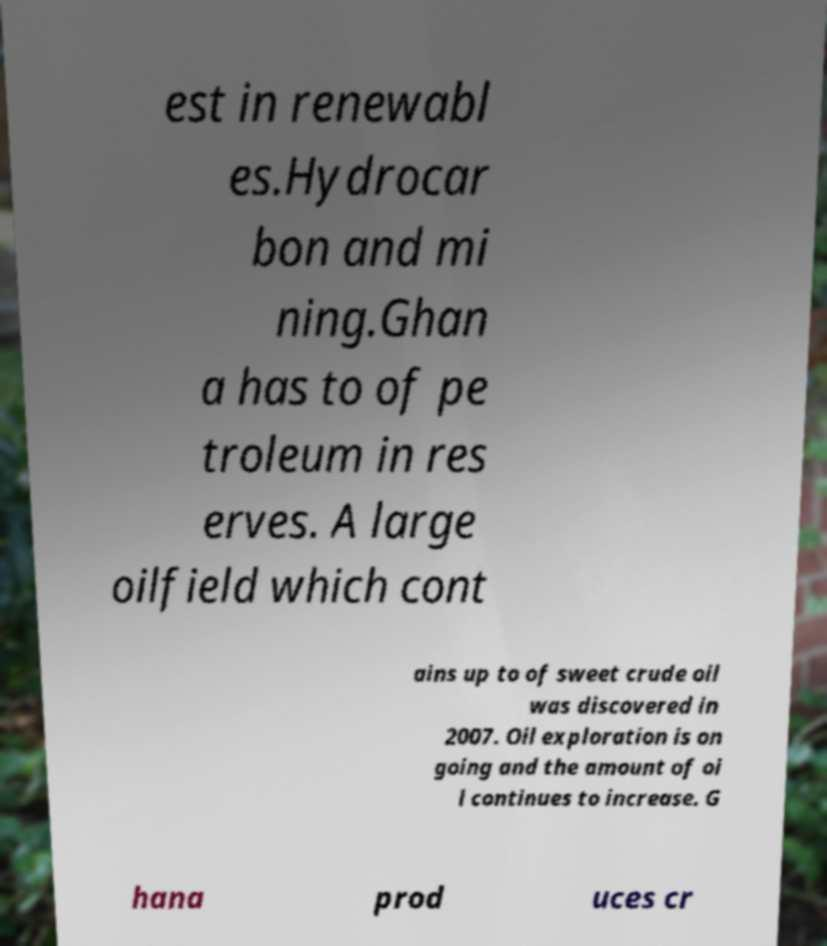For documentation purposes, I need the text within this image transcribed. Could you provide that? est in renewabl es.Hydrocar bon and mi ning.Ghan a has to of pe troleum in res erves. A large oilfield which cont ains up to of sweet crude oil was discovered in 2007. Oil exploration is on going and the amount of oi l continues to increase. G hana prod uces cr 